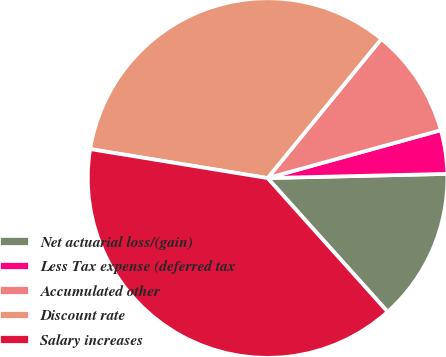<chart> <loc_0><loc_0><loc_500><loc_500><pie_chart><fcel>Net actuarial loss/(gain)<fcel>Less Tax expense (deferred tax<fcel>Accumulated other<fcel>Discount rate<fcel>Salary increases<nl><fcel>13.73%<fcel>3.92%<fcel>9.8%<fcel>33.33%<fcel>39.22%<nl></chart> 